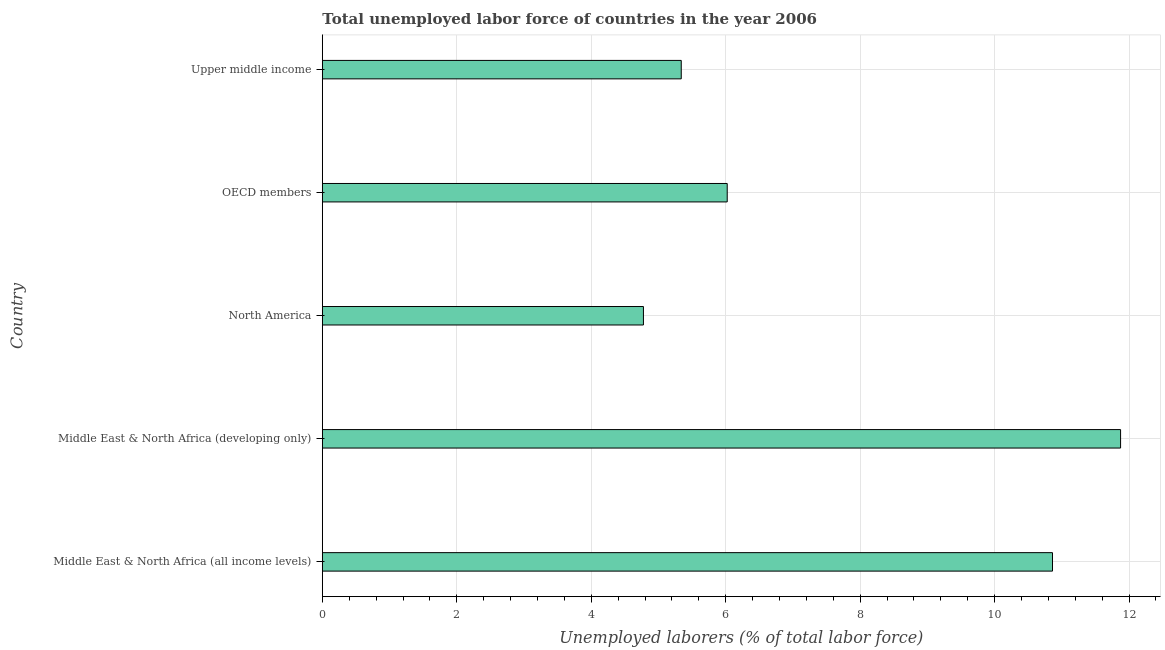Does the graph contain any zero values?
Your answer should be very brief. No. Does the graph contain grids?
Offer a very short reply. Yes. What is the title of the graph?
Ensure brevity in your answer.  Total unemployed labor force of countries in the year 2006. What is the label or title of the X-axis?
Give a very brief answer. Unemployed laborers (% of total labor force). What is the total unemployed labour force in OECD members?
Provide a short and direct response. 6.02. Across all countries, what is the maximum total unemployed labour force?
Give a very brief answer. 11.87. Across all countries, what is the minimum total unemployed labour force?
Your response must be concise. 4.78. In which country was the total unemployed labour force maximum?
Keep it short and to the point. Middle East & North Africa (developing only). What is the sum of the total unemployed labour force?
Provide a short and direct response. 38.87. What is the difference between the total unemployed labour force in Middle East & North Africa (developing only) and OECD members?
Give a very brief answer. 5.85. What is the average total unemployed labour force per country?
Your answer should be very brief. 7.78. What is the median total unemployed labour force?
Offer a terse response. 6.02. In how many countries, is the total unemployed labour force greater than 3.2 %?
Your answer should be compact. 5. What is the ratio of the total unemployed labour force in Middle East & North Africa (all income levels) to that in North America?
Your answer should be compact. 2.27. Is the total unemployed labour force in Middle East & North Africa (developing only) less than that in Upper middle income?
Ensure brevity in your answer.  No. Is the difference between the total unemployed labour force in Middle East & North Africa (all income levels) and Upper middle income greater than the difference between any two countries?
Provide a succinct answer. No. In how many countries, is the total unemployed labour force greater than the average total unemployed labour force taken over all countries?
Your response must be concise. 2. What is the Unemployed laborers (% of total labor force) in Middle East & North Africa (all income levels)?
Keep it short and to the point. 10.86. What is the Unemployed laborers (% of total labor force) of Middle East & North Africa (developing only)?
Keep it short and to the point. 11.87. What is the Unemployed laborers (% of total labor force) in North America?
Provide a succinct answer. 4.78. What is the Unemployed laborers (% of total labor force) in OECD members?
Keep it short and to the point. 6.02. What is the Unemployed laborers (% of total labor force) of Upper middle income?
Give a very brief answer. 5.34. What is the difference between the Unemployed laborers (% of total labor force) in Middle East & North Africa (all income levels) and Middle East & North Africa (developing only)?
Offer a terse response. -1.01. What is the difference between the Unemployed laborers (% of total labor force) in Middle East & North Africa (all income levels) and North America?
Ensure brevity in your answer.  6.08. What is the difference between the Unemployed laborers (% of total labor force) in Middle East & North Africa (all income levels) and OECD members?
Make the answer very short. 4.84. What is the difference between the Unemployed laborers (% of total labor force) in Middle East & North Africa (all income levels) and Upper middle income?
Give a very brief answer. 5.52. What is the difference between the Unemployed laborers (% of total labor force) in Middle East & North Africa (developing only) and North America?
Give a very brief answer. 7.1. What is the difference between the Unemployed laborers (% of total labor force) in Middle East & North Africa (developing only) and OECD members?
Keep it short and to the point. 5.85. What is the difference between the Unemployed laborers (% of total labor force) in Middle East & North Africa (developing only) and Upper middle income?
Provide a short and direct response. 6.53. What is the difference between the Unemployed laborers (% of total labor force) in North America and OECD members?
Keep it short and to the point. -1.25. What is the difference between the Unemployed laborers (% of total labor force) in North America and Upper middle income?
Your answer should be very brief. -0.56. What is the difference between the Unemployed laborers (% of total labor force) in OECD members and Upper middle income?
Ensure brevity in your answer.  0.68. What is the ratio of the Unemployed laborers (% of total labor force) in Middle East & North Africa (all income levels) to that in Middle East & North Africa (developing only)?
Give a very brief answer. 0.92. What is the ratio of the Unemployed laborers (% of total labor force) in Middle East & North Africa (all income levels) to that in North America?
Ensure brevity in your answer.  2.27. What is the ratio of the Unemployed laborers (% of total labor force) in Middle East & North Africa (all income levels) to that in OECD members?
Offer a very short reply. 1.8. What is the ratio of the Unemployed laborers (% of total labor force) in Middle East & North Africa (all income levels) to that in Upper middle income?
Offer a terse response. 2.03. What is the ratio of the Unemployed laborers (% of total labor force) in Middle East & North Africa (developing only) to that in North America?
Offer a very short reply. 2.49. What is the ratio of the Unemployed laborers (% of total labor force) in Middle East & North Africa (developing only) to that in OECD members?
Keep it short and to the point. 1.97. What is the ratio of the Unemployed laborers (% of total labor force) in Middle East & North Africa (developing only) to that in Upper middle income?
Offer a very short reply. 2.22. What is the ratio of the Unemployed laborers (% of total labor force) in North America to that in OECD members?
Your answer should be very brief. 0.79. What is the ratio of the Unemployed laborers (% of total labor force) in North America to that in Upper middle income?
Provide a succinct answer. 0.9. What is the ratio of the Unemployed laborers (% of total labor force) in OECD members to that in Upper middle income?
Make the answer very short. 1.13. 